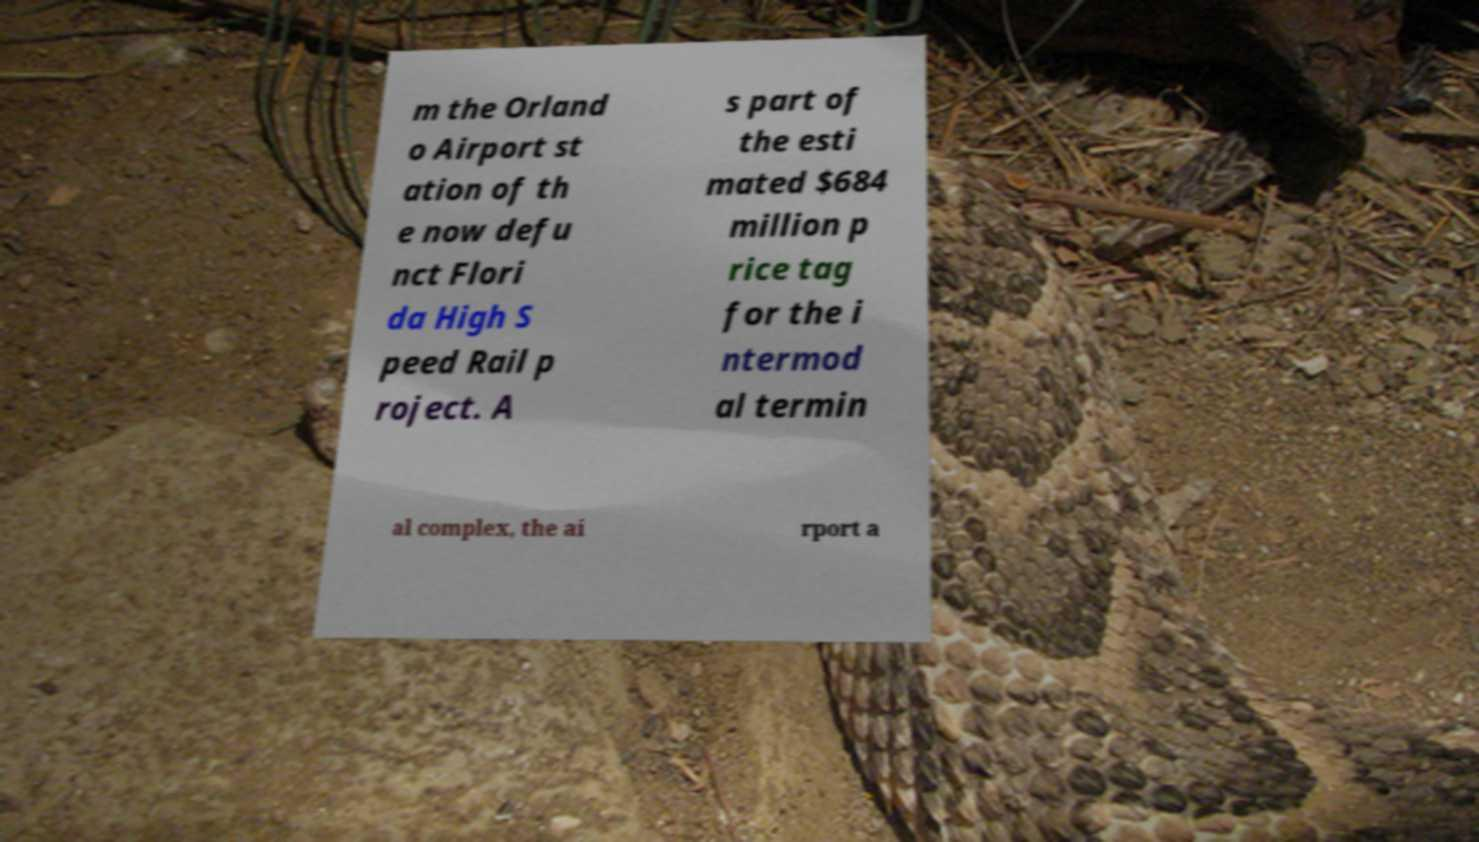Please read and relay the text visible in this image. What does it say? m the Orland o Airport st ation of th e now defu nct Flori da High S peed Rail p roject. A s part of the esti mated $684 million p rice tag for the i ntermod al termin al complex, the ai rport a 